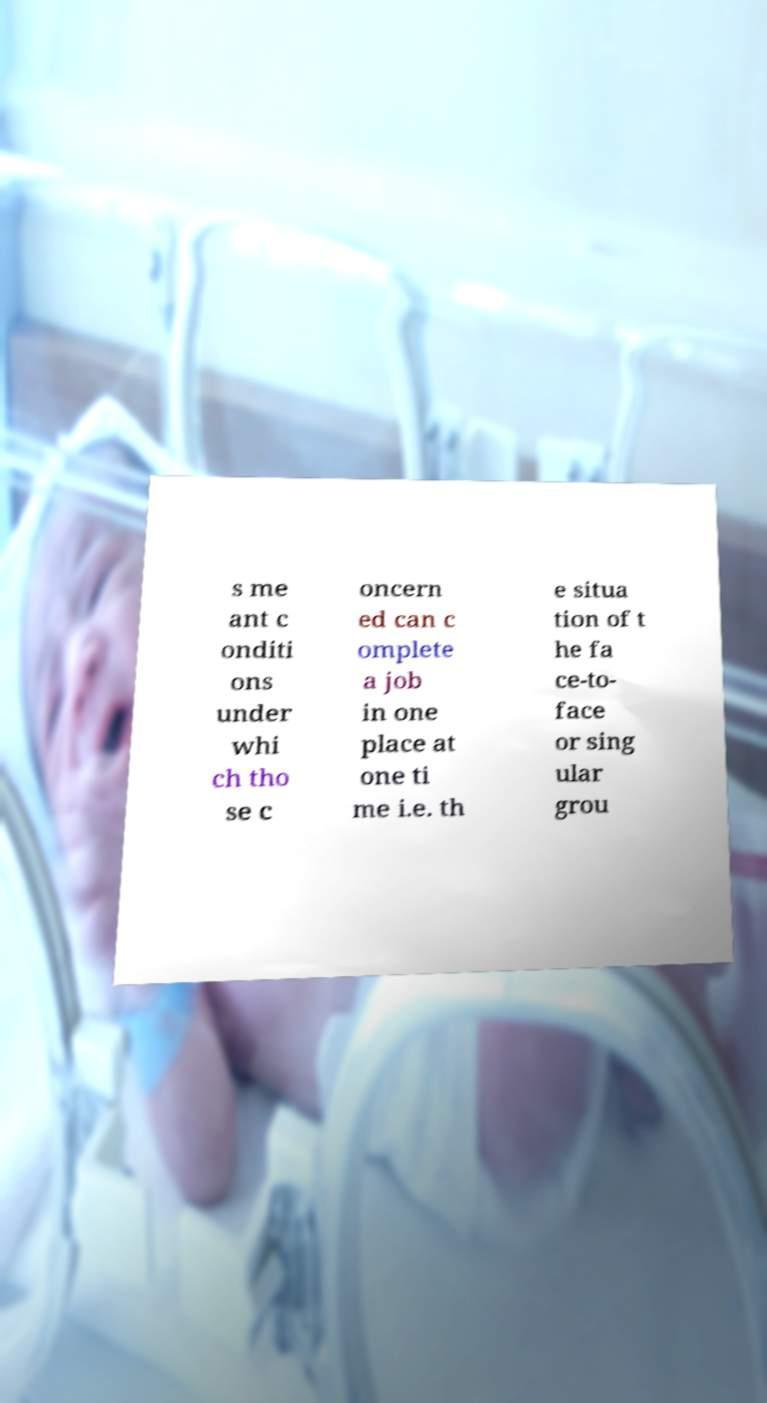Could you extract and type out the text from this image? s me ant c onditi ons under whi ch tho se c oncern ed can c omplete a job in one place at one ti me i.e. th e situa tion of t he fa ce-to- face or sing ular grou 